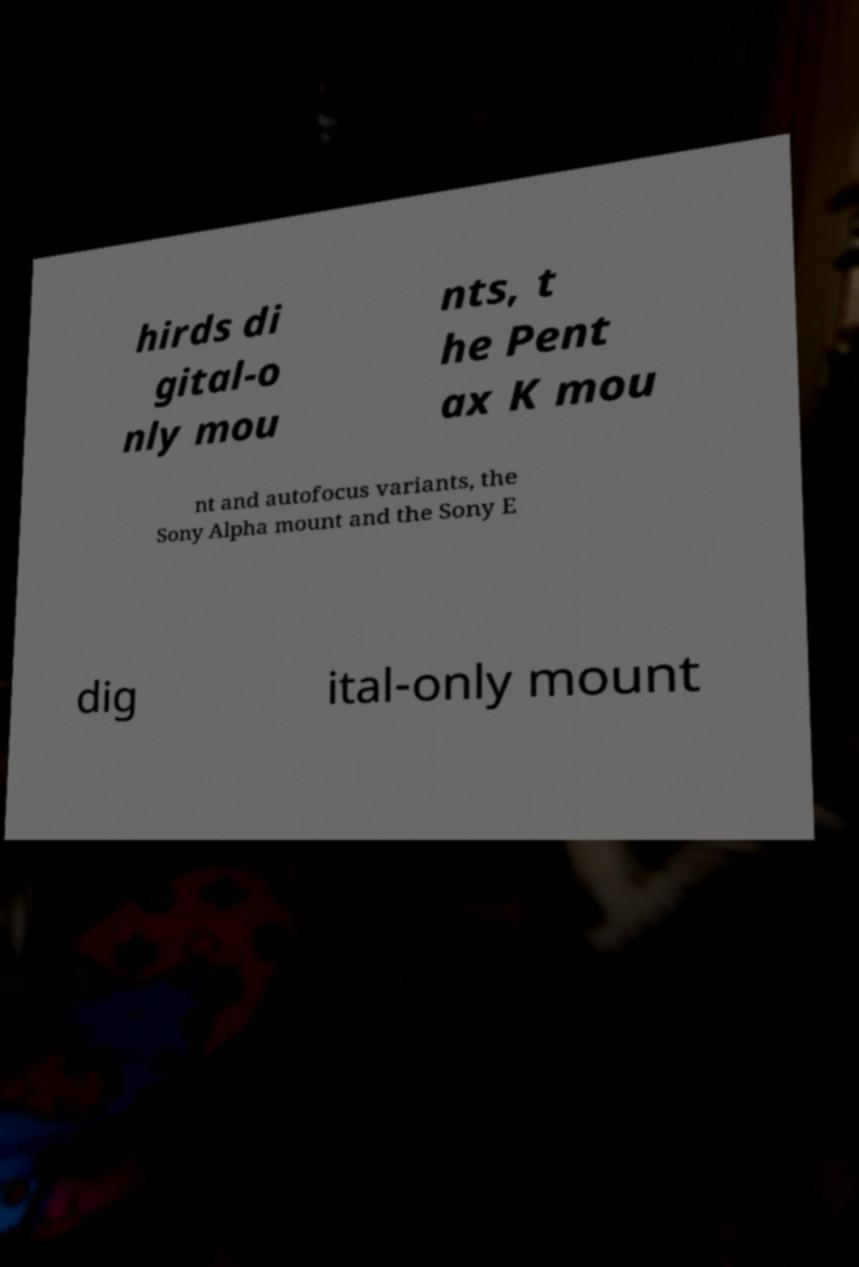For documentation purposes, I need the text within this image transcribed. Could you provide that? hirds di gital-o nly mou nts, t he Pent ax K mou nt and autofocus variants, the Sony Alpha mount and the Sony E dig ital-only mount 